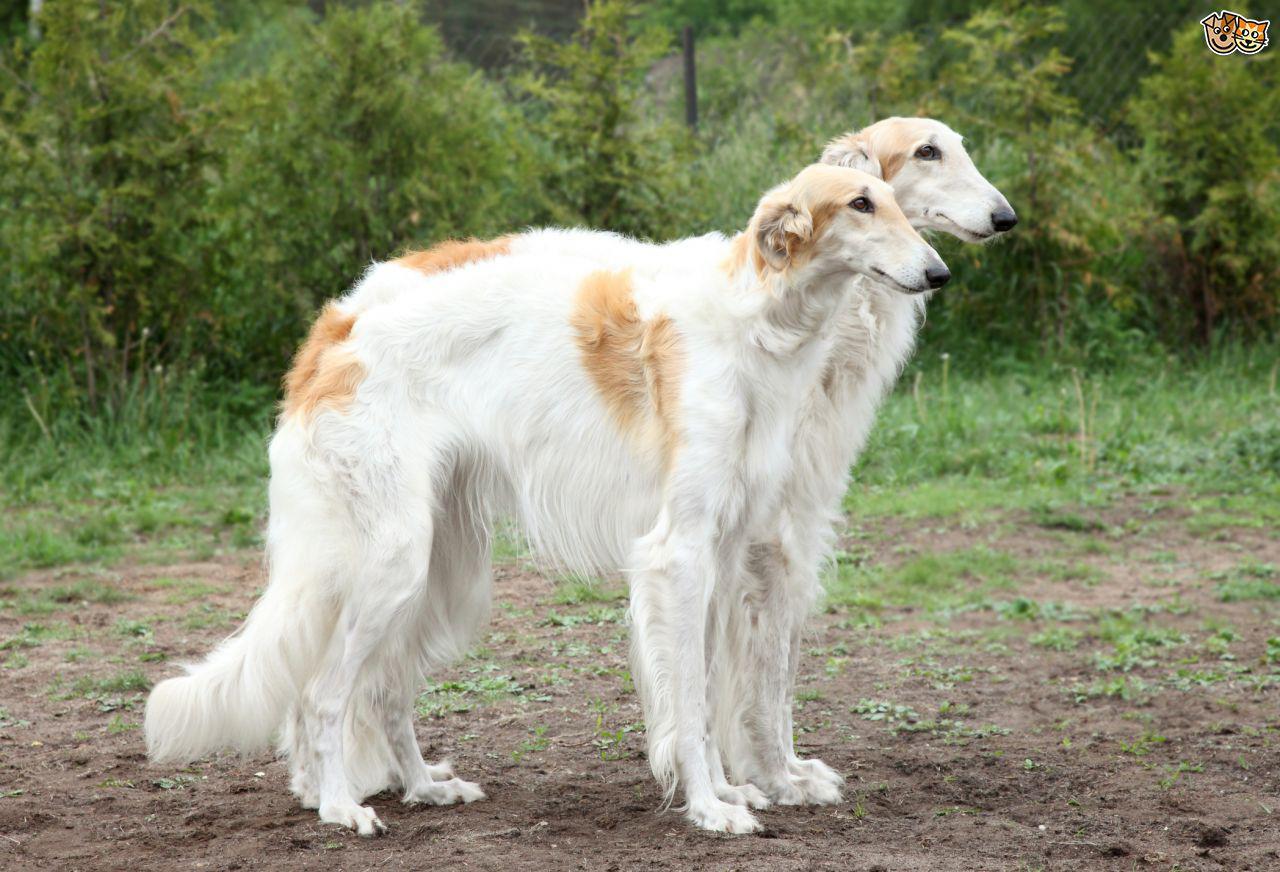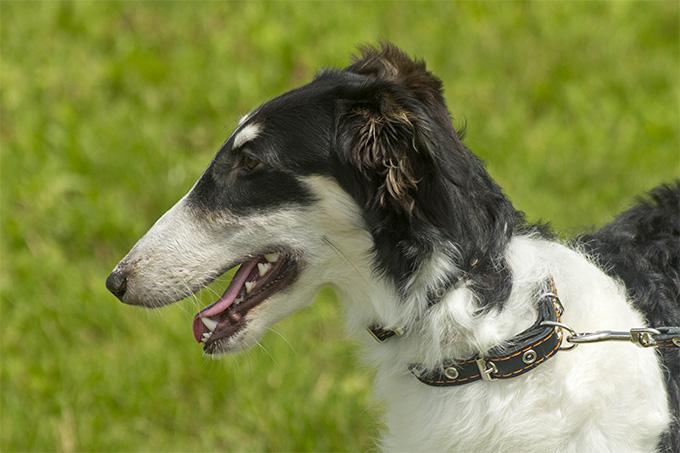The first image is the image on the left, the second image is the image on the right. For the images shown, is this caption "The left image shows one reddish-orange and white dog in full profile, facing left." true? Answer yes or no. No. 